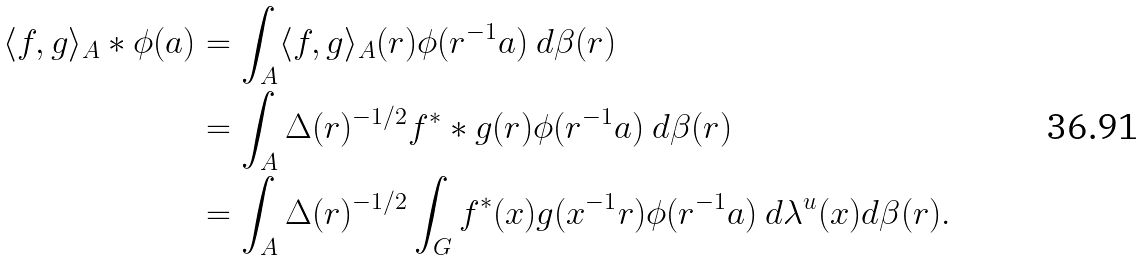<formula> <loc_0><loc_0><loc_500><loc_500>\langle f , g \rangle _ { A } * \phi ( a ) & = \int _ { A } \langle f , g \rangle _ { A } ( r ) \phi ( r ^ { - 1 } a ) \ d \beta ( r ) \\ & = \int _ { A } \Delta ( r ) ^ { - 1 / 2 } f ^ { * } * g ( r ) \phi ( r ^ { - 1 } a ) \ d \beta ( r ) \\ & = \int _ { A } \Delta ( r ) ^ { - 1 / 2 } \int _ { G } f ^ { * } ( x ) g ( x ^ { - 1 } r ) \phi ( r ^ { - 1 } a ) \ d \lambda ^ { u } ( x ) d \beta ( r ) .</formula> 